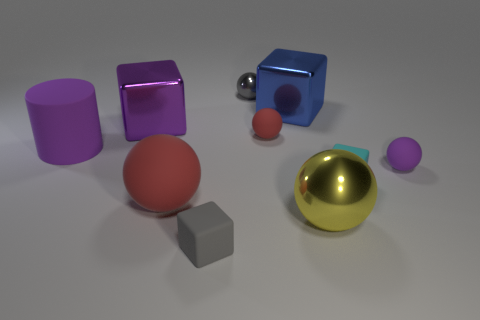Subtract 1 cubes. How many cubes are left? 3 Subtract all cyan balls. Subtract all purple cubes. How many balls are left? 5 Subtract all cylinders. How many objects are left? 9 Subtract 0 green cubes. How many objects are left? 10 Subtract all large spheres. Subtract all gray cylinders. How many objects are left? 8 Add 7 shiny cubes. How many shiny cubes are left? 9 Add 3 small purple rubber balls. How many small purple rubber balls exist? 4 